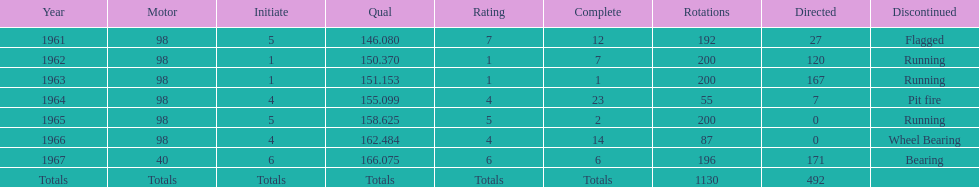What is the difference between the qualfying time in 1967 and 1965? 7.45. 